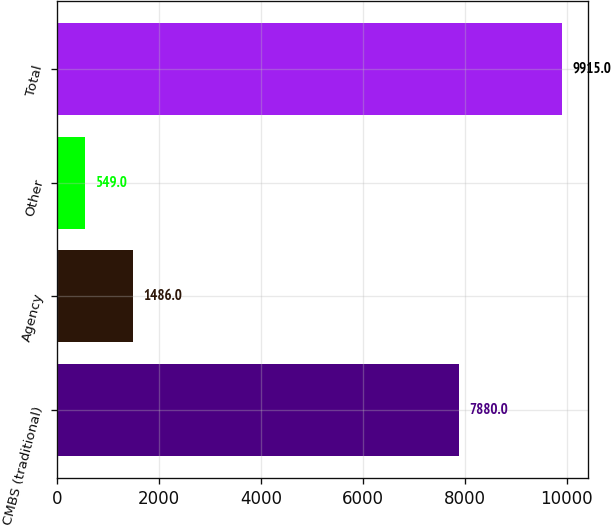Convert chart to OTSL. <chart><loc_0><loc_0><loc_500><loc_500><bar_chart><fcel>CMBS (traditional)<fcel>Agency<fcel>Other<fcel>Total<nl><fcel>7880<fcel>1486<fcel>549<fcel>9915<nl></chart> 